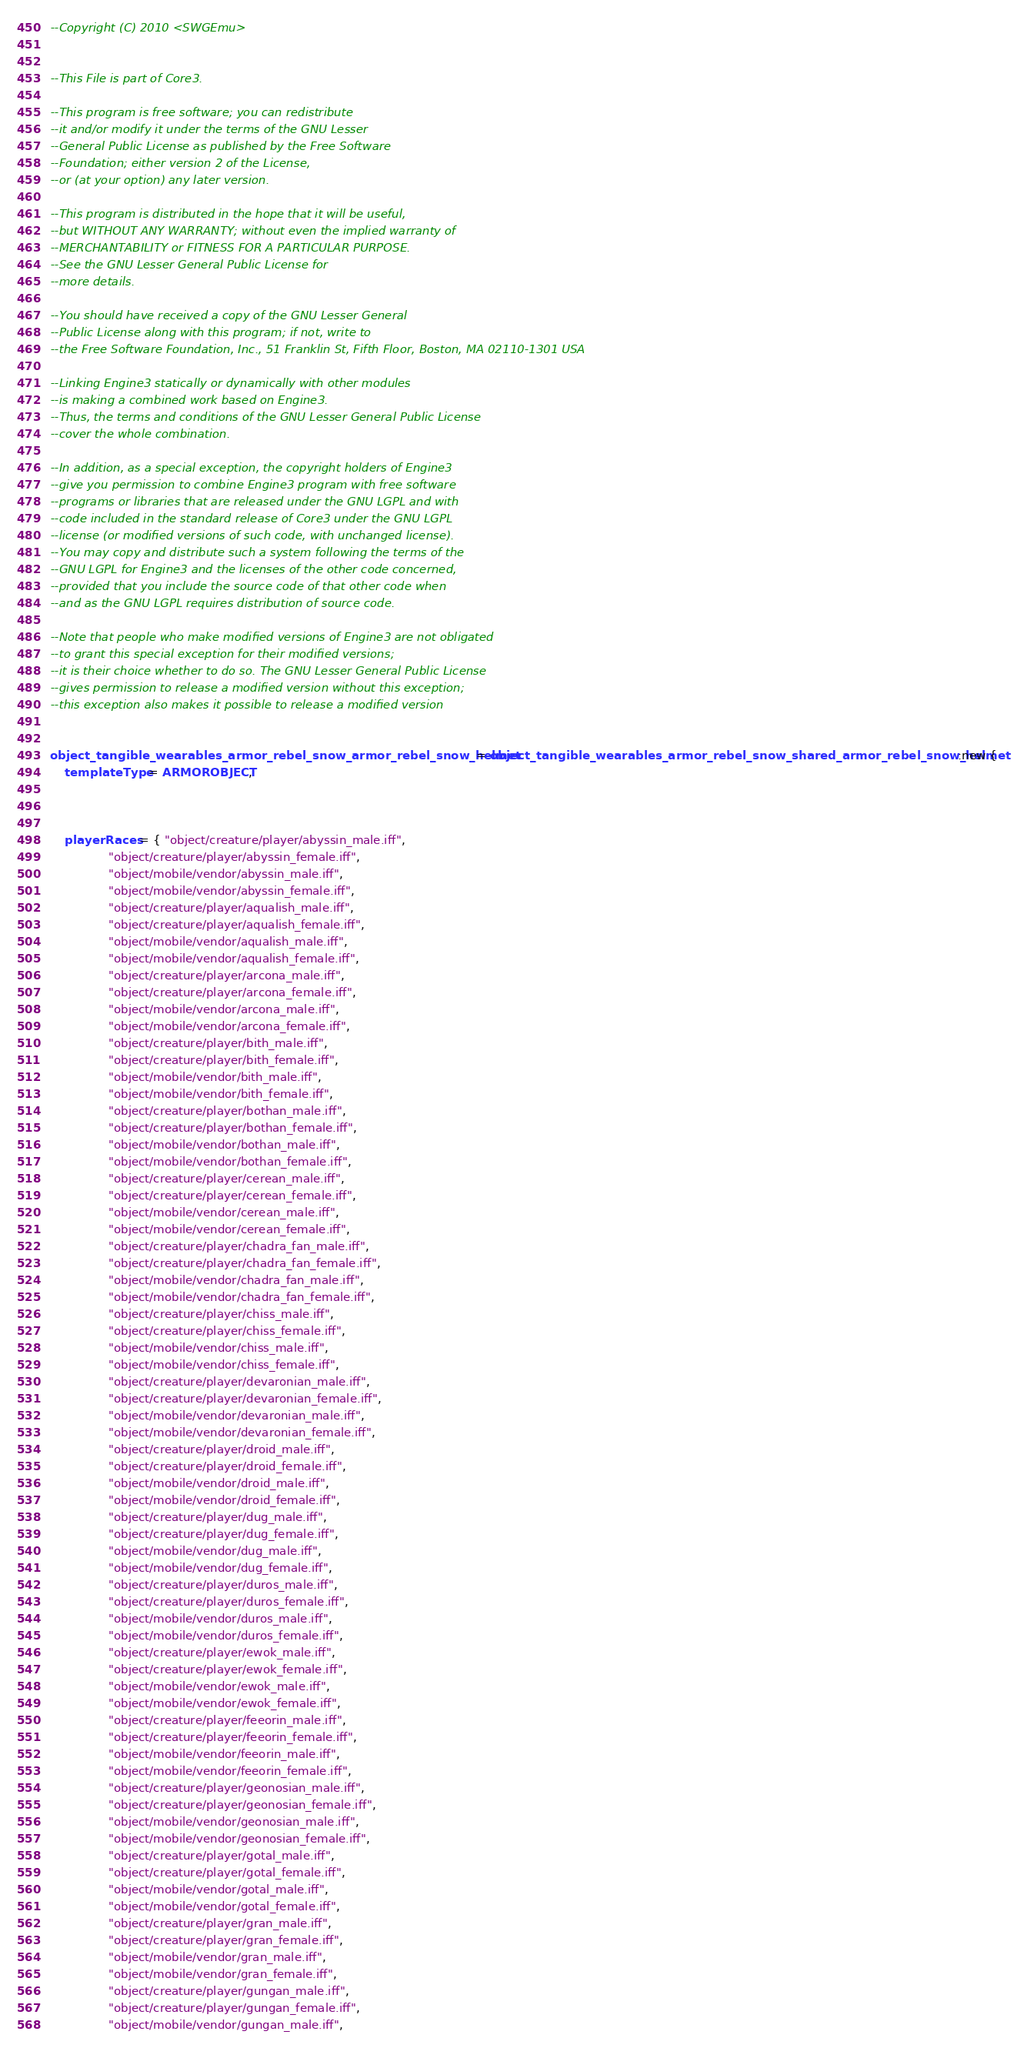<code> <loc_0><loc_0><loc_500><loc_500><_Lua_>--Copyright (C) 2010 <SWGEmu>


--This File is part of Core3.

--This program is free software; you can redistribute 
--it and/or modify it under the terms of the GNU Lesser 
--General Public License as published by the Free Software
--Foundation; either version 2 of the License, 
--or (at your option) any later version.

--This program is distributed in the hope that it will be useful, 
--but WITHOUT ANY WARRANTY; without even the implied warranty of 
--MERCHANTABILITY or FITNESS FOR A PARTICULAR PURPOSE. 
--See the GNU Lesser General Public License for
--more details.

--You should have received a copy of the GNU Lesser General 
--Public License along with this program; if not, write to
--the Free Software Foundation, Inc., 51 Franklin St, Fifth Floor, Boston, MA 02110-1301 USA

--Linking Engine3 statically or dynamically with other modules 
--is making a combined work based on Engine3. 
--Thus, the terms and conditions of the GNU Lesser General Public License 
--cover the whole combination.

--In addition, as a special exception, the copyright holders of Engine3 
--give you permission to combine Engine3 program with free software 
--programs or libraries that are released under the GNU LGPL and with 
--code included in the standard release of Core3 under the GNU LGPL 
--license (or modified versions of such code, with unchanged license). 
--You may copy and distribute such a system following the terms of the 
--GNU LGPL for Engine3 and the licenses of the other code concerned, 
--provided that you include the source code of that other code when 
--and as the GNU LGPL requires distribution of source code.

--Note that people who make modified versions of Engine3 are not obligated 
--to grant this special exception for their modified versions; 
--it is their choice whether to do so. The GNU Lesser General Public License 
--gives permission to release a modified version without this exception; 
--this exception also makes it possible to release a modified version 


object_tangible_wearables_armor_rebel_snow_armor_rebel_snow_helmet = object_tangible_wearables_armor_rebel_snow_shared_armor_rebel_snow_helmet:new {
	templateType = ARMOROBJECT,



	playerRaces = { "object/creature/player/abyssin_male.iff",
				"object/creature/player/abyssin_female.iff",
				"object/mobile/vendor/abyssin_male.iff",
				"object/mobile/vendor/abyssin_female.iff",
				"object/creature/player/aqualish_male.iff",
				"object/creature/player/aqualish_female.iff",
				"object/mobile/vendor/aqualish_male.iff",
				"object/mobile/vendor/aqualish_female.iff",
				"object/creature/player/arcona_male.iff",
				"object/creature/player/arcona_female.iff",
				"object/mobile/vendor/arcona_male.iff",
				"object/mobile/vendor/arcona_female.iff",
				"object/creature/player/bith_male.iff",
				"object/creature/player/bith_female.iff",
				"object/mobile/vendor/bith_male.iff",
				"object/mobile/vendor/bith_female.iff",
				"object/creature/player/bothan_male.iff",
				"object/creature/player/bothan_female.iff",
				"object/mobile/vendor/bothan_male.iff",
				"object/mobile/vendor/bothan_female.iff",
				"object/creature/player/cerean_male.iff",
				"object/creature/player/cerean_female.iff",
				"object/mobile/vendor/cerean_male.iff",
				"object/mobile/vendor/cerean_female.iff",
				"object/creature/player/chadra_fan_male.iff",
				"object/creature/player/chadra_fan_female.iff",
				"object/mobile/vendor/chadra_fan_male.iff",
				"object/mobile/vendor/chadra_fan_female.iff",
				"object/creature/player/chiss_male.iff",
				"object/creature/player/chiss_female.iff",
				"object/mobile/vendor/chiss_male.iff",
				"object/mobile/vendor/chiss_female.iff",
				"object/creature/player/devaronian_male.iff",
				"object/creature/player/devaronian_female.iff",
				"object/mobile/vendor/devaronian_male.iff",
				"object/mobile/vendor/devaronian_female.iff",
				"object/creature/player/droid_male.iff",
				"object/creature/player/droid_female.iff",
				"object/mobile/vendor/droid_male.iff",
				"object/mobile/vendor/droid_female.iff",
				"object/creature/player/dug_male.iff",
				"object/creature/player/dug_female.iff",
				"object/mobile/vendor/dug_male.iff",
				"object/mobile/vendor/dug_female.iff",
				"object/creature/player/duros_male.iff",
				"object/creature/player/duros_female.iff",
				"object/mobile/vendor/duros_male.iff",
				"object/mobile/vendor/duros_female.iff",
				"object/creature/player/ewok_male.iff",
				"object/creature/player/ewok_female.iff",
				"object/mobile/vendor/ewok_male.iff",
				"object/mobile/vendor/ewok_female.iff",
				"object/creature/player/feeorin_male.iff",
				"object/creature/player/feeorin_female.iff",
				"object/mobile/vendor/feeorin_male.iff",
				"object/mobile/vendor/feeorin_female.iff",
				"object/creature/player/geonosian_male.iff",
				"object/creature/player/geonosian_female.iff",
				"object/mobile/vendor/geonosian_male.iff",
				"object/mobile/vendor/geonosian_female.iff",
				"object/creature/player/gotal_male.iff",
				"object/creature/player/gotal_female.iff",
				"object/mobile/vendor/gotal_male.iff",
				"object/mobile/vendor/gotal_female.iff",
				"object/creature/player/gran_male.iff",
				"object/creature/player/gran_female.iff",
				"object/mobile/vendor/gran_male.iff",
				"object/mobile/vendor/gran_female.iff",
				"object/creature/player/gungan_male.iff",
				"object/creature/player/gungan_female.iff",
				"object/mobile/vendor/gungan_male.iff",</code> 